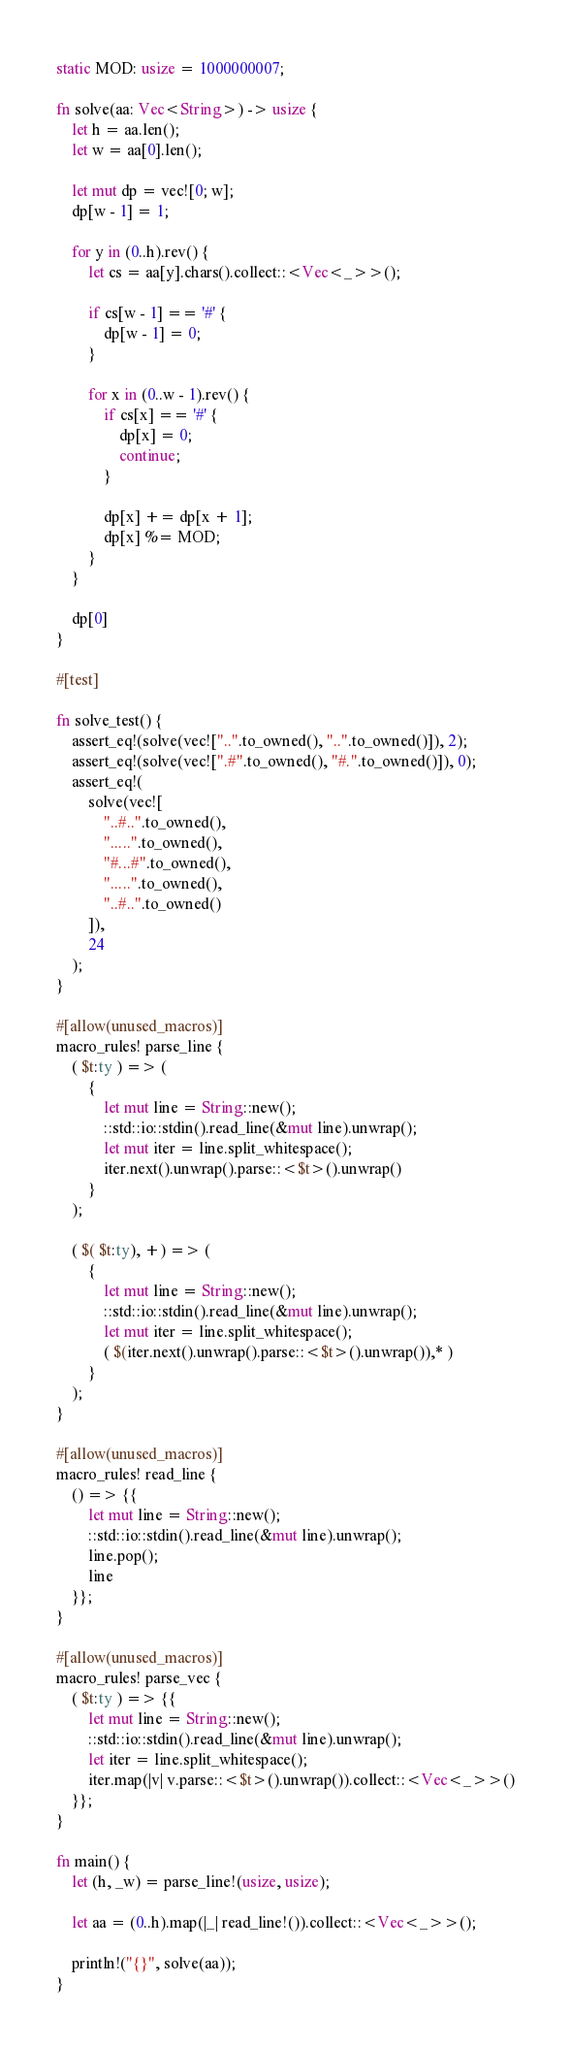<code> <loc_0><loc_0><loc_500><loc_500><_Rust_>static MOD: usize = 1000000007;

fn solve(aa: Vec<String>) -> usize {
    let h = aa.len();
    let w = aa[0].len();

    let mut dp = vec![0; w];
    dp[w - 1] = 1;

    for y in (0..h).rev() {
        let cs = aa[y].chars().collect::<Vec<_>>();

        if cs[w - 1] == '#' {
            dp[w - 1] = 0;
        }

        for x in (0..w - 1).rev() {
            if cs[x] == '#' {
                dp[x] = 0;
                continue;
            }

            dp[x] += dp[x + 1];
            dp[x] %= MOD;
        }
    }

    dp[0]
}

#[test]

fn solve_test() {
    assert_eq!(solve(vec!["..".to_owned(), "..".to_owned()]), 2);
    assert_eq!(solve(vec![".#".to_owned(), "#.".to_owned()]), 0);
    assert_eq!(
        solve(vec![
            "..#..".to_owned(),
            ".....".to_owned(),
            "#...#".to_owned(),
            ".....".to_owned(),
            "..#..".to_owned()
        ]),
        24
    );
}

#[allow(unused_macros)]
macro_rules! parse_line {
    ( $t:ty ) => (
        {
            let mut line = String::new();
            ::std::io::stdin().read_line(&mut line).unwrap();
            let mut iter = line.split_whitespace();
            iter.next().unwrap().parse::<$t>().unwrap()
        }
    );

    ( $( $t:ty), +) => (
        {
            let mut line = String::new();
            ::std::io::stdin().read_line(&mut line).unwrap();
            let mut iter = line.split_whitespace();
            ( $(iter.next().unwrap().parse::<$t>().unwrap()),* )
        }
    );
}

#[allow(unused_macros)]
macro_rules! read_line {
    () => {{
        let mut line = String::new();
        ::std::io::stdin().read_line(&mut line).unwrap();
        line.pop();
        line
    }};
}

#[allow(unused_macros)]
macro_rules! parse_vec {
    ( $t:ty ) => {{
        let mut line = String::new();
        ::std::io::stdin().read_line(&mut line).unwrap();
        let iter = line.split_whitespace();
        iter.map(|v| v.parse::<$t>().unwrap()).collect::<Vec<_>>()
    }};
}

fn main() {
    let (h, _w) = parse_line!(usize, usize);

    let aa = (0..h).map(|_| read_line!()).collect::<Vec<_>>();

    println!("{}", solve(aa));
}
</code> 